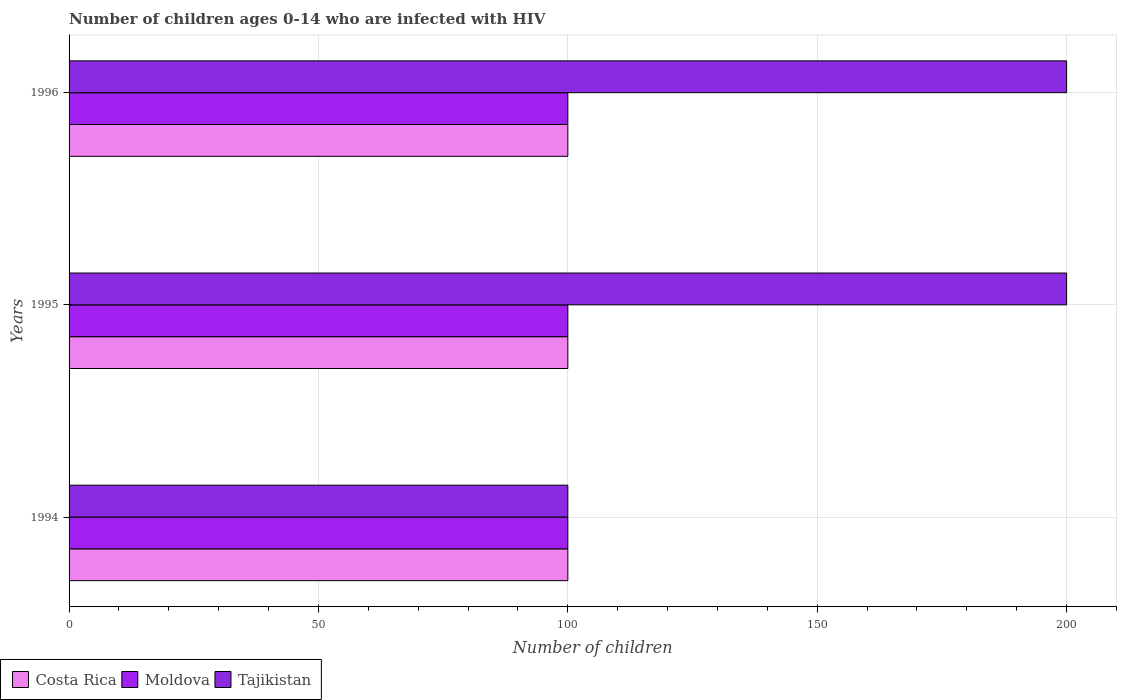How many different coloured bars are there?
Keep it short and to the point. 3. Are the number of bars on each tick of the Y-axis equal?
Provide a short and direct response. Yes. How many bars are there on the 1st tick from the top?
Your answer should be very brief. 3. How many bars are there on the 2nd tick from the bottom?
Make the answer very short. 3. What is the label of the 2nd group of bars from the top?
Your response must be concise. 1995. In how many cases, is the number of bars for a given year not equal to the number of legend labels?
Offer a very short reply. 0. What is the number of HIV infected children in Costa Rica in 1995?
Your answer should be compact. 100. Across all years, what is the maximum number of HIV infected children in Tajikistan?
Ensure brevity in your answer.  200. Across all years, what is the minimum number of HIV infected children in Costa Rica?
Offer a terse response. 100. In which year was the number of HIV infected children in Tajikistan minimum?
Offer a very short reply. 1994. What is the total number of HIV infected children in Moldova in the graph?
Provide a short and direct response. 300. What is the difference between the number of HIV infected children in Tajikistan in 1995 and that in 1996?
Offer a very short reply. 0. What is the difference between the number of HIV infected children in Costa Rica in 1994 and the number of HIV infected children in Tajikistan in 1996?
Make the answer very short. -100. Is the difference between the number of HIV infected children in Tajikistan in 1995 and 1996 greater than the difference between the number of HIV infected children in Moldova in 1995 and 1996?
Keep it short and to the point. No. In how many years, is the number of HIV infected children in Costa Rica greater than the average number of HIV infected children in Costa Rica taken over all years?
Offer a very short reply. 0. Is the sum of the number of HIV infected children in Tajikistan in 1994 and 1995 greater than the maximum number of HIV infected children in Moldova across all years?
Your answer should be very brief. Yes. What does the 3rd bar from the top in 1996 represents?
Offer a very short reply. Costa Rica. What does the 3rd bar from the bottom in 1994 represents?
Offer a terse response. Tajikistan. How many bars are there?
Your answer should be very brief. 9. Are all the bars in the graph horizontal?
Provide a short and direct response. Yes. Are the values on the major ticks of X-axis written in scientific E-notation?
Provide a succinct answer. No. Where does the legend appear in the graph?
Keep it short and to the point. Bottom left. How many legend labels are there?
Your response must be concise. 3. How are the legend labels stacked?
Provide a short and direct response. Horizontal. What is the title of the graph?
Ensure brevity in your answer.  Number of children ages 0-14 who are infected with HIV. What is the label or title of the X-axis?
Make the answer very short. Number of children. What is the label or title of the Y-axis?
Your answer should be compact. Years. What is the Number of children in Costa Rica in 1994?
Ensure brevity in your answer.  100. What is the Number of children in Tajikistan in 1994?
Your response must be concise. 100. Across all years, what is the maximum Number of children in Costa Rica?
Your answer should be compact. 100. Across all years, what is the maximum Number of children of Moldova?
Offer a very short reply. 100. Across all years, what is the minimum Number of children in Moldova?
Keep it short and to the point. 100. Across all years, what is the minimum Number of children of Tajikistan?
Offer a very short reply. 100. What is the total Number of children of Costa Rica in the graph?
Make the answer very short. 300. What is the total Number of children in Moldova in the graph?
Provide a short and direct response. 300. What is the difference between the Number of children of Tajikistan in 1994 and that in 1995?
Provide a succinct answer. -100. What is the difference between the Number of children in Tajikistan in 1994 and that in 1996?
Your answer should be compact. -100. What is the difference between the Number of children in Costa Rica in 1995 and that in 1996?
Keep it short and to the point. 0. What is the difference between the Number of children of Moldova in 1995 and that in 1996?
Provide a short and direct response. 0. What is the difference between the Number of children of Tajikistan in 1995 and that in 1996?
Ensure brevity in your answer.  0. What is the difference between the Number of children of Costa Rica in 1994 and the Number of children of Moldova in 1995?
Keep it short and to the point. 0. What is the difference between the Number of children in Costa Rica in 1994 and the Number of children in Tajikistan in 1995?
Offer a very short reply. -100. What is the difference between the Number of children of Moldova in 1994 and the Number of children of Tajikistan in 1995?
Offer a very short reply. -100. What is the difference between the Number of children in Costa Rica in 1994 and the Number of children in Moldova in 1996?
Keep it short and to the point. 0. What is the difference between the Number of children in Costa Rica in 1994 and the Number of children in Tajikistan in 1996?
Offer a very short reply. -100. What is the difference between the Number of children in Moldova in 1994 and the Number of children in Tajikistan in 1996?
Provide a short and direct response. -100. What is the difference between the Number of children in Costa Rica in 1995 and the Number of children in Moldova in 1996?
Make the answer very short. 0. What is the difference between the Number of children in Costa Rica in 1995 and the Number of children in Tajikistan in 1996?
Your answer should be very brief. -100. What is the difference between the Number of children of Moldova in 1995 and the Number of children of Tajikistan in 1996?
Your response must be concise. -100. What is the average Number of children of Moldova per year?
Make the answer very short. 100. What is the average Number of children in Tajikistan per year?
Make the answer very short. 166.67. In the year 1994, what is the difference between the Number of children in Costa Rica and Number of children in Tajikistan?
Offer a terse response. 0. In the year 1995, what is the difference between the Number of children of Costa Rica and Number of children of Moldova?
Offer a terse response. 0. In the year 1995, what is the difference between the Number of children of Costa Rica and Number of children of Tajikistan?
Provide a short and direct response. -100. In the year 1995, what is the difference between the Number of children of Moldova and Number of children of Tajikistan?
Ensure brevity in your answer.  -100. In the year 1996, what is the difference between the Number of children of Costa Rica and Number of children of Tajikistan?
Give a very brief answer. -100. In the year 1996, what is the difference between the Number of children of Moldova and Number of children of Tajikistan?
Provide a short and direct response. -100. What is the ratio of the Number of children of Costa Rica in 1994 to that in 1995?
Provide a succinct answer. 1. What is the ratio of the Number of children in Moldova in 1994 to that in 1995?
Your answer should be very brief. 1. What is the ratio of the Number of children in Tajikistan in 1994 to that in 1995?
Your response must be concise. 0.5. What is the ratio of the Number of children of Moldova in 1994 to that in 1996?
Your answer should be very brief. 1. What is the difference between the highest and the second highest Number of children in Costa Rica?
Offer a terse response. 0. What is the difference between the highest and the second highest Number of children of Tajikistan?
Keep it short and to the point. 0. What is the difference between the highest and the lowest Number of children of Moldova?
Provide a short and direct response. 0. What is the difference between the highest and the lowest Number of children in Tajikistan?
Your answer should be very brief. 100. 